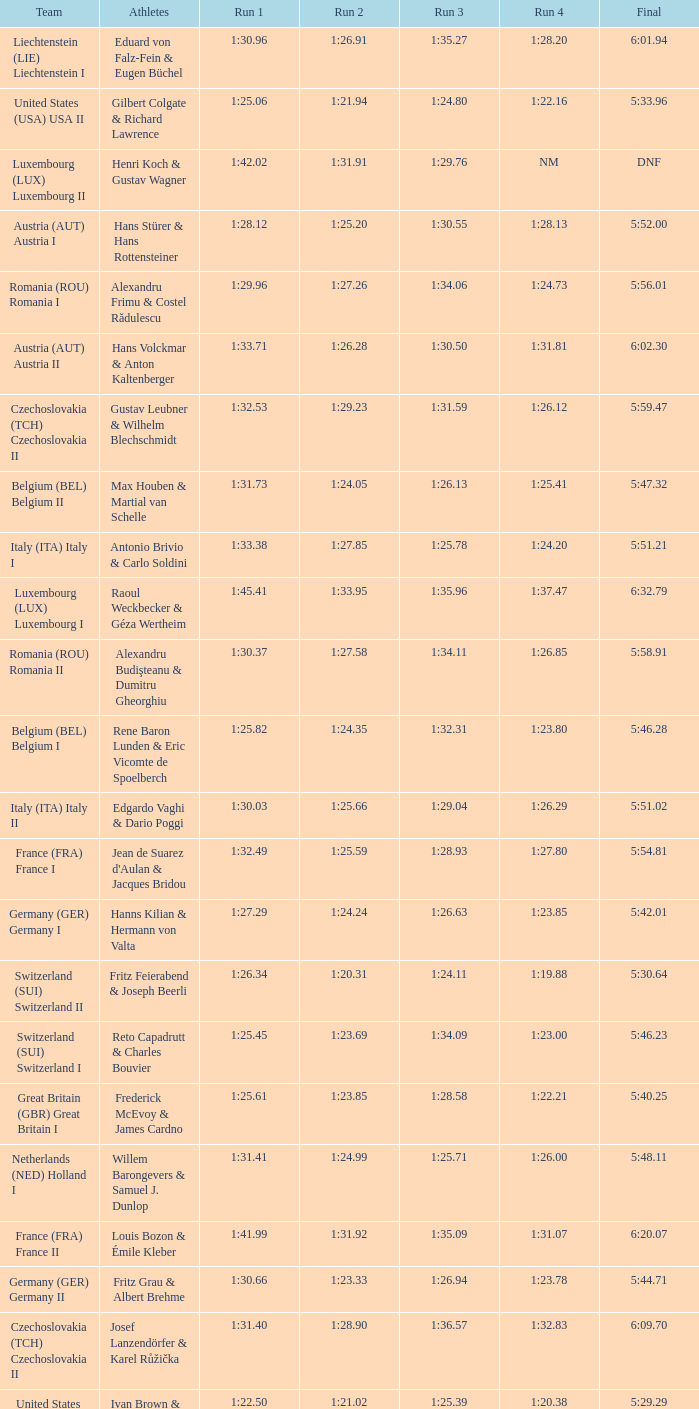Which Run 4 has a Run 3 of 1:26.63? 1:23.85. 